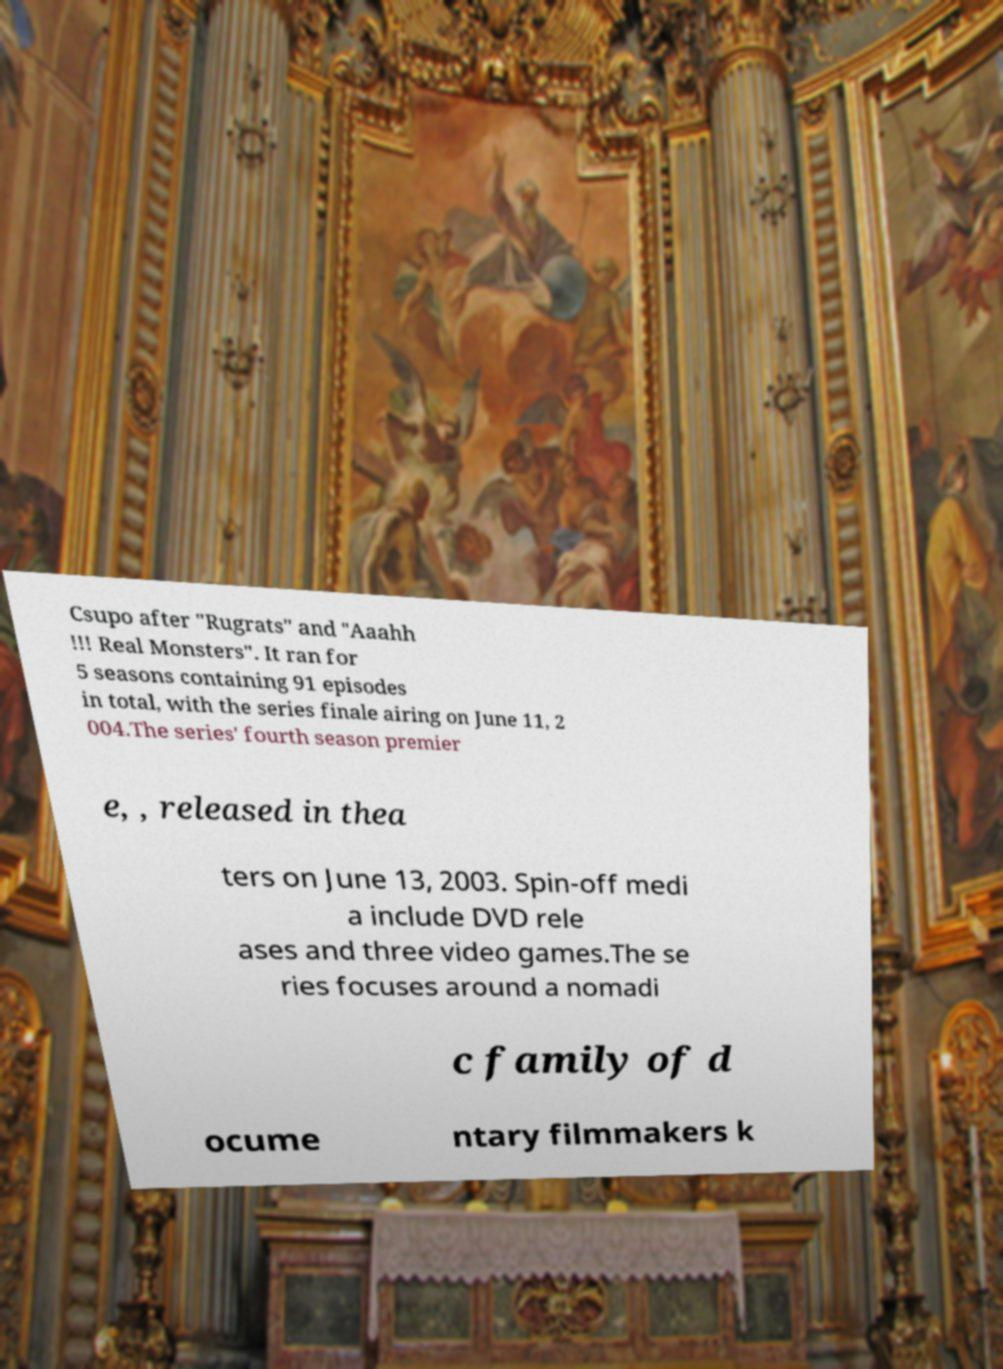I need the written content from this picture converted into text. Can you do that? Csupo after "Rugrats" and "Aaahh !!! Real Monsters". It ran for 5 seasons containing 91 episodes in total, with the series finale airing on June 11, 2 004.The series' fourth season premier e, , released in thea ters on June 13, 2003. Spin-off medi a include DVD rele ases and three video games.The se ries focuses around a nomadi c family of d ocume ntary filmmakers k 